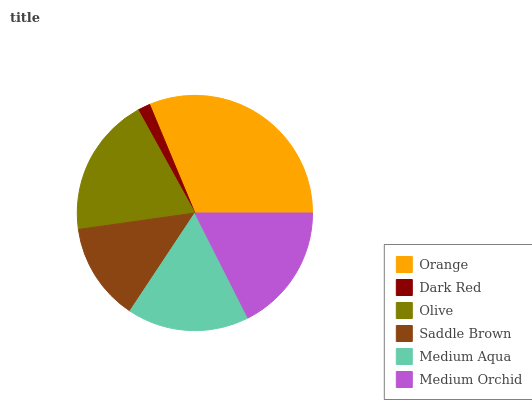Is Dark Red the minimum?
Answer yes or no. Yes. Is Orange the maximum?
Answer yes or no. Yes. Is Olive the minimum?
Answer yes or no. No. Is Olive the maximum?
Answer yes or no. No. Is Olive greater than Dark Red?
Answer yes or no. Yes. Is Dark Red less than Olive?
Answer yes or no. Yes. Is Dark Red greater than Olive?
Answer yes or no. No. Is Olive less than Dark Red?
Answer yes or no. No. Is Medium Orchid the high median?
Answer yes or no. Yes. Is Medium Aqua the low median?
Answer yes or no. Yes. Is Saddle Brown the high median?
Answer yes or no. No. Is Olive the low median?
Answer yes or no. No. 